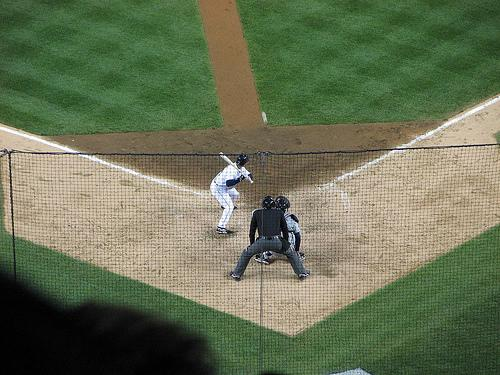Describe the position of the batter in terms of his readiness to hit the baseball. The batter is about to hit the baseball, with the bat in a ready position. Provide a brief description of the primary colors present in the image. The primary colors in the image are green, brown, white, and black. What pattern can be observed on the grass in the image? The grass is mowed in a checkered or square pattern. Mention two objects that have the same color in the image. The ball is white, and the bat is also white. Which sport is being played in the image, and how many players can you see? Baseball is being played, and there are at least four players visible. Explain the position of the catcher in relation to the umpire in the image. The catcher stands in front of the umpire, getting ready to catch the baseball. Describe the type of ground seen in the image. The ground is a mixture of green grass and brown dirt in a baseball field. In a poetic manner, describe the moment captured in the image. Amidst green turf and brown earth, men in white and black play the game of baseball; a white ball soars, waiting to meet its destiny with the bat. What type of protective gear is being worn by a player in the image? A black baseball helmet is being worn by a player. In a dramatic and intense manner, describe the scene unfolding in the image. The tension heightens as the batter focuses intensely, ready to unleash a powerful swing on the approaching white ball, while the catcher and the umpire brace themselves, prepared for the outcome of this nail-biting moment. 